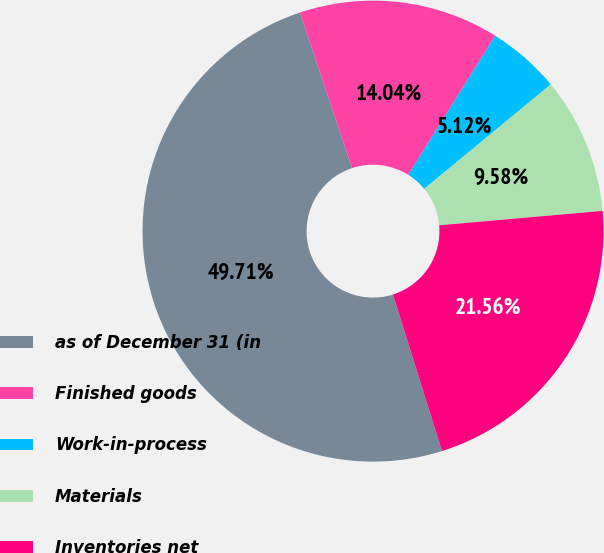Convert chart to OTSL. <chart><loc_0><loc_0><loc_500><loc_500><pie_chart><fcel>as of December 31 (in<fcel>Finished goods<fcel>Work-in-process<fcel>Materials<fcel>Inventories net<nl><fcel>49.71%<fcel>14.04%<fcel>5.12%<fcel>9.58%<fcel>21.56%<nl></chart> 